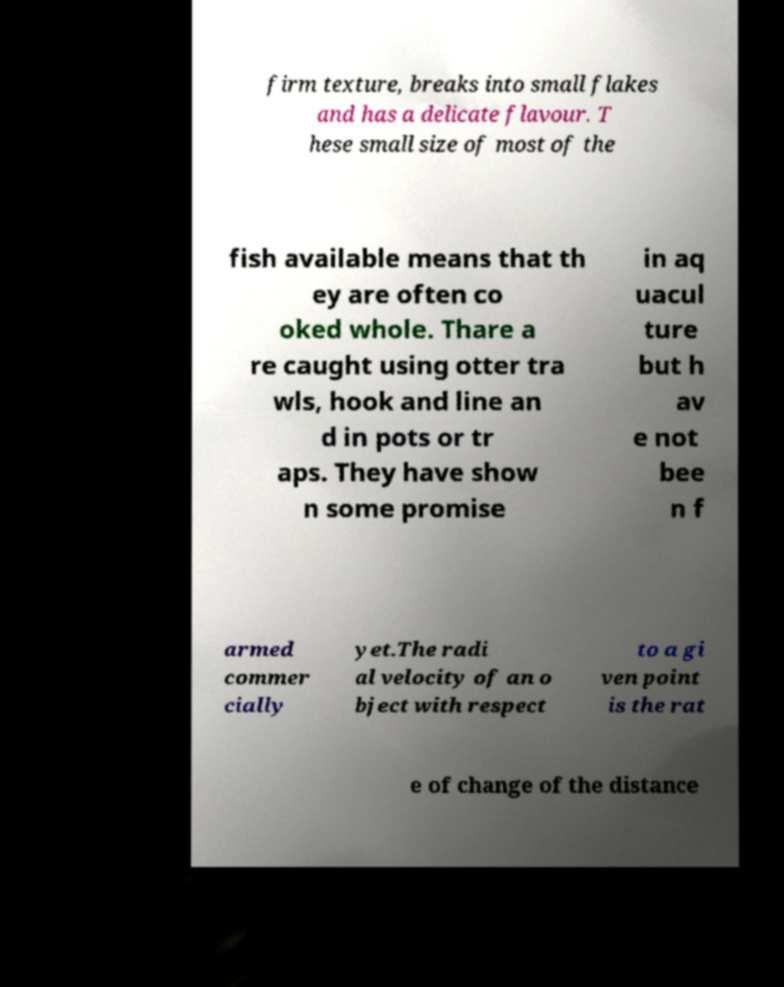Please read and relay the text visible in this image. What does it say? firm texture, breaks into small flakes and has a delicate flavour. T hese small size of most of the fish available means that th ey are often co oked whole. Thare a re caught using otter tra wls, hook and line an d in pots or tr aps. They have show n some promise in aq uacul ture but h av e not bee n f armed commer cially yet.The radi al velocity of an o bject with respect to a gi ven point is the rat e of change of the distance 